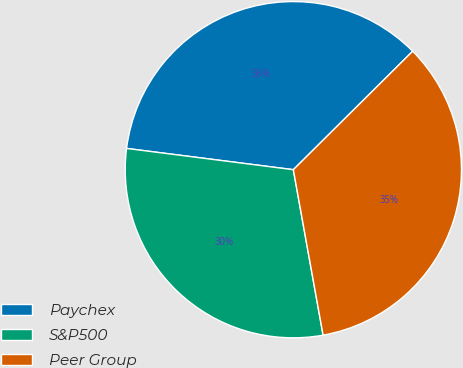Convert chart. <chart><loc_0><loc_0><loc_500><loc_500><pie_chart><fcel>Paychex<fcel>S&P500<fcel>Peer Group<nl><fcel>35.54%<fcel>29.85%<fcel>34.61%<nl></chart> 